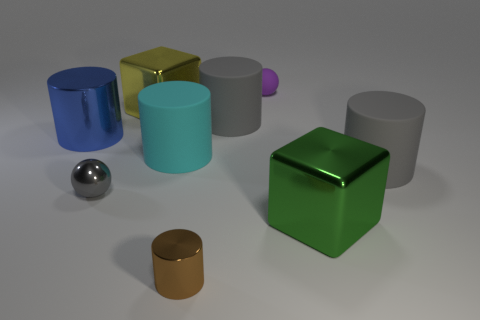Subtract all small cylinders. How many cylinders are left? 4 Subtract all green blocks. How many blocks are left? 1 Subtract 3 cylinders. How many cylinders are left? 2 Subtract all yellow spheres. How many brown cylinders are left? 1 Subtract all cylinders. How many objects are left? 4 Subtract all red cylinders. Subtract all yellow spheres. How many cylinders are left? 5 Subtract all tiny purple rubber spheres. Subtract all large yellow objects. How many objects are left? 7 Add 4 tiny matte objects. How many tiny matte objects are left? 5 Add 7 big gray things. How many big gray things exist? 9 Subtract 0 red blocks. How many objects are left? 9 